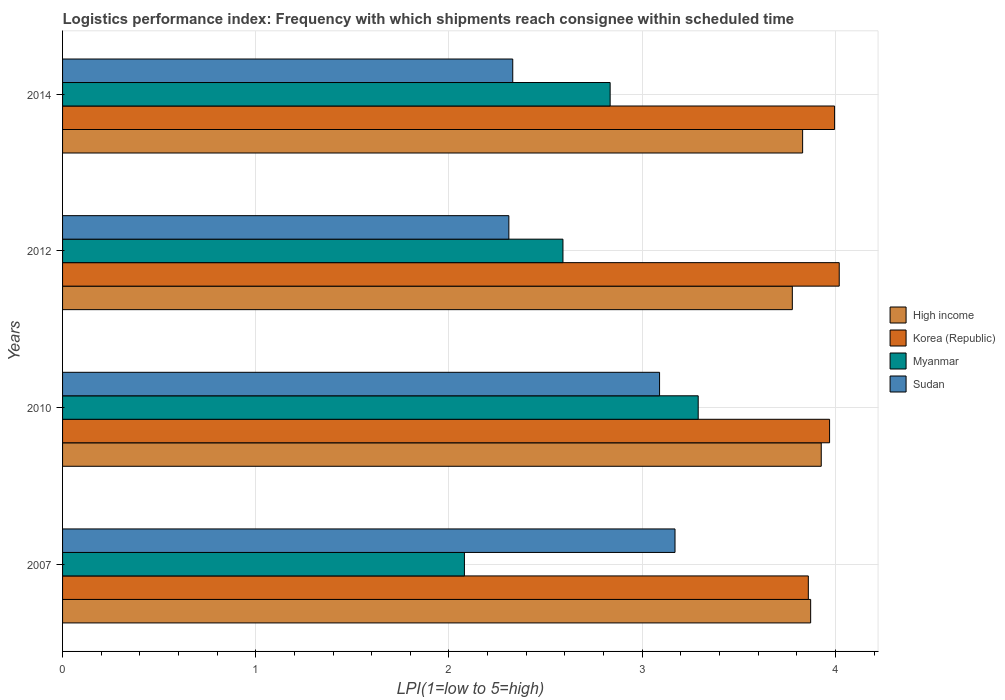Are the number of bars per tick equal to the number of legend labels?
Ensure brevity in your answer.  Yes. Are the number of bars on each tick of the Y-axis equal?
Your answer should be compact. Yes. What is the label of the 3rd group of bars from the top?
Your answer should be very brief. 2010. In how many cases, is the number of bars for a given year not equal to the number of legend labels?
Offer a terse response. 0. What is the logistics performance index in Korea (Republic) in 2007?
Provide a short and direct response. 3.86. Across all years, what is the maximum logistics performance index in High income?
Make the answer very short. 3.93. Across all years, what is the minimum logistics performance index in High income?
Provide a short and direct response. 3.78. What is the total logistics performance index in Sudan in the graph?
Your answer should be very brief. 10.9. What is the difference between the logistics performance index in High income in 2007 and that in 2010?
Ensure brevity in your answer.  -0.05. What is the difference between the logistics performance index in Sudan in 2014 and the logistics performance index in Myanmar in 2007?
Keep it short and to the point. 0.25. What is the average logistics performance index in Korea (Republic) per year?
Ensure brevity in your answer.  3.96. In the year 2007, what is the difference between the logistics performance index in Korea (Republic) and logistics performance index in High income?
Your answer should be compact. -0.01. In how many years, is the logistics performance index in Sudan greater than 1 ?
Make the answer very short. 4. What is the ratio of the logistics performance index in Myanmar in 2007 to that in 2014?
Your response must be concise. 0.73. Is the logistics performance index in Sudan in 2010 less than that in 2012?
Your answer should be very brief. No. Is the difference between the logistics performance index in Korea (Republic) in 2010 and 2012 greater than the difference between the logistics performance index in High income in 2010 and 2012?
Your response must be concise. No. What is the difference between the highest and the second highest logistics performance index in High income?
Give a very brief answer. 0.05. What is the difference between the highest and the lowest logistics performance index in Korea (Republic)?
Provide a short and direct response. 0.16. In how many years, is the logistics performance index in High income greater than the average logistics performance index in High income taken over all years?
Provide a succinct answer. 2. Is the sum of the logistics performance index in Korea (Republic) in 2007 and 2012 greater than the maximum logistics performance index in High income across all years?
Your response must be concise. Yes. What does the 4th bar from the top in 2014 represents?
Your answer should be compact. High income. What does the 3rd bar from the bottom in 2010 represents?
Give a very brief answer. Myanmar. How many bars are there?
Make the answer very short. 16. Does the graph contain any zero values?
Your response must be concise. No. How are the legend labels stacked?
Offer a very short reply. Vertical. What is the title of the graph?
Keep it short and to the point. Logistics performance index: Frequency with which shipments reach consignee within scheduled time. What is the label or title of the X-axis?
Your answer should be very brief. LPI(1=low to 5=high). What is the label or title of the Y-axis?
Provide a short and direct response. Years. What is the LPI(1=low to 5=high) of High income in 2007?
Your response must be concise. 3.87. What is the LPI(1=low to 5=high) in Korea (Republic) in 2007?
Make the answer very short. 3.86. What is the LPI(1=low to 5=high) in Myanmar in 2007?
Give a very brief answer. 2.08. What is the LPI(1=low to 5=high) of Sudan in 2007?
Make the answer very short. 3.17. What is the LPI(1=low to 5=high) in High income in 2010?
Give a very brief answer. 3.93. What is the LPI(1=low to 5=high) of Korea (Republic) in 2010?
Your response must be concise. 3.97. What is the LPI(1=low to 5=high) in Myanmar in 2010?
Offer a very short reply. 3.29. What is the LPI(1=low to 5=high) of Sudan in 2010?
Your response must be concise. 3.09. What is the LPI(1=low to 5=high) of High income in 2012?
Keep it short and to the point. 3.78. What is the LPI(1=low to 5=high) of Korea (Republic) in 2012?
Your answer should be very brief. 4.02. What is the LPI(1=low to 5=high) in Myanmar in 2012?
Offer a very short reply. 2.59. What is the LPI(1=low to 5=high) in Sudan in 2012?
Your response must be concise. 2.31. What is the LPI(1=low to 5=high) of High income in 2014?
Offer a very short reply. 3.83. What is the LPI(1=low to 5=high) of Korea (Republic) in 2014?
Provide a short and direct response. 4. What is the LPI(1=low to 5=high) in Myanmar in 2014?
Keep it short and to the point. 2.83. What is the LPI(1=low to 5=high) in Sudan in 2014?
Ensure brevity in your answer.  2.33. Across all years, what is the maximum LPI(1=low to 5=high) of High income?
Make the answer very short. 3.93. Across all years, what is the maximum LPI(1=low to 5=high) in Korea (Republic)?
Your response must be concise. 4.02. Across all years, what is the maximum LPI(1=low to 5=high) in Myanmar?
Your answer should be compact. 3.29. Across all years, what is the maximum LPI(1=low to 5=high) of Sudan?
Keep it short and to the point. 3.17. Across all years, what is the minimum LPI(1=low to 5=high) in High income?
Keep it short and to the point. 3.78. Across all years, what is the minimum LPI(1=low to 5=high) in Korea (Republic)?
Offer a terse response. 3.86. Across all years, what is the minimum LPI(1=low to 5=high) in Myanmar?
Ensure brevity in your answer.  2.08. Across all years, what is the minimum LPI(1=low to 5=high) in Sudan?
Offer a very short reply. 2.31. What is the total LPI(1=low to 5=high) of High income in the graph?
Provide a short and direct response. 15.41. What is the total LPI(1=low to 5=high) of Korea (Republic) in the graph?
Ensure brevity in your answer.  15.85. What is the total LPI(1=low to 5=high) of Myanmar in the graph?
Provide a short and direct response. 10.79. What is the total LPI(1=low to 5=high) in Sudan in the graph?
Your answer should be very brief. 10.9. What is the difference between the LPI(1=low to 5=high) in High income in 2007 and that in 2010?
Offer a very short reply. -0.05. What is the difference between the LPI(1=low to 5=high) in Korea (Republic) in 2007 and that in 2010?
Your answer should be compact. -0.11. What is the difference between the LPI(1=low to 5=high) of Myanmar in 2007 and that in 2010?
Give a very brief answer. -1.21. What is the difference between the LPI(1=low to 5=high) in High income in 2007 and that in 2012?
Your answer should be very brief. 0.09. What is the difference between the LPI(1=low to 5=high) in Korea (Republic) in 2007 and that in 2012?
Your answer should be very brief. -0.16. What is the difference between the LPI(1=low to 5=high) of Myanmar in 2007 and that in 2012?
Give a very brief answer. -0.51. What is the difference between the LPI(1=low to 5=high) in Sudan in 2007 and that in 2012?
Offer a terse response. 0.86. What is the difference between the LPI(1=low to 5=high) in High income in 2007 and that in 2014?
Make the answer very short. 0.04. What is the difference between the LPI(1=low to 5=high) in Korea (Republic) in 2007 and that in 2014?
Ensure brevity in your answer.  -0.14. What is the difference between the LPI(1=low to 5=high) of Myanmar in 2007 and that in 2014?
Offer a terse response. -0.75. What is the difference between the LPI(1=low to 5=high) of Sudan in 2007 and that in 2014?
Provide a short and direct response. 0.84. What is the difference between the LPI(1=low to 5=high) of High income in 2010 and that in 2012?
Offer a very short reply. 0.15. What is the difference between the LPI(1=low to 5=high) in Myanmar in 2010 and that in 2012?
Give a very brief answer. 0.7. What is the difference between the LPI(1=low to 5=high) in Sudan in 2010 and that in 2012?
Your answer should be very brief. 0.78. What is the difference between the LPI(1=low to 5=high) of High income in 2010 and that in 2014?
Ensure brevity in your answer.  0.1. What is the difference between the LPI(1=low to 5=high) in Korea (Republic) in 2010 and that in 2014?
Provide a succinct answer. -0.03. What is the difference between the LPI(1=low to 5=high) of Myanmar in 2010 and that in 2014?
Provide a succinct answer. 0.46. What is the difference between the LPI(1=low to 5=high) of Sudan in 2010 and that in 2014?
Ensure brevity in your answer.  0.76. What is the difference between the LPI(1=low to 5=high) of High income in 2012 and that in 2014?
Keep it short and to the point. -0.05. What is the difference between the LPI(1=low to 5=high) in Korea (Republic) in 2012 and that in 2014?
Offer a terse response. 0.02. What is the difference between the LPI(1=low to 5=high) in Myanmar in 2012 and that in 2014?
Offer a very short reply. -0.24. What is the difference between the LPI(1=low to 5=high) of Sudan in 2012 and that in 2014?
Keep it short and to the point. -0.02. What is the difference between the LPI(1=low to 5=high) of High income in 2007 and the LPI(1=low to 5=high) of Korea (Republic) in 2010?
Provide a succinct answer. -0.1. What is the difference between the LPI(1=low to 5=high) of High income in 2007 and the LPI(1=low to 5=high) of Myanmar in 2010?
Provide a succinct answer. 0.58. What is the difference between the LPI(1=low to 5=high) in High income in 2007 and the LPI(1=low to 5=high) in Sudan in 2010?
Offer a terse response. 0.78. What is the difference between the LPI(1=low to 5=high) of Korea (Republic) in 2007 and the LPI(1=low to 5=high) of Myanmar in 2010?
Keep it short and to the point. 0.57. What is the difference between the LPI(1=low to 5=high) in Korea (Republic) in 2007 and the LPI(1=low to 5=high) in Sudan in 2010?
Give a very brief answer. 0.77. What is the difference between the LPI(1=low to 5=high) in Myanmar in 2007 and the LPI(1=low to 5=high) in Sudan in 2010?
Provide a short and direct response. -1.01. What is the difference between the LPI(1=low to 5=high) in High income in 2007 and the LPI(1=low to 5=high) in Korea (Republic) in 2012?
Offer a very short reply. -0.15. What is the difference between the LPI(1=low to 5=high) of High income in 2007 and the LPI(1=low to 5=high) of Myanmar in 2012?
Your answer should be very brief. 1.28. What is the difference between the LPI(1=low to 5=high) of High income in 2007 and the LPI(1=low to 5=high) of Sudan in 2012?
Your answer should be very brief. 1.56. What is the difference between the LPI(1=low to 5=high) of Korea (Republic) in 2007 and the LPI(1=low to 5=high) of Myanmar in 2012?
Your answer should be very brief. 1.27. What is the difference between the LPI(1=low to 5=high) in Korea (Republic) in 2007 and the LPI(1=low to 5=high) in Sudan in 2012?
Offer a terse response. 1.55. What is the difference between the LPI(1=low to 5=high) in Myanmar in 2007 and the LPI(1=low to 5=high) in Sudan in 2012?
Your response must be concise. -0.23. What is the difference between the LPI(1=low to 5=high) of High income in 2007 and the LPI(1=low to 5=high) of Korea (Republic) in 2014?
Ensure brevity in your answer.  -0.12. What is the difference between the LPI(1=low to 5=high) of High income in 2007 and the LPI(1=low to 5=high) of Myanmar in 2014?
Offer a terse response. 1.04. What is the difference between the LPI(1=low to 5=high) of High income in 2007 and the LPI(1=low to 5=high) of Sudan in 2014?
Provide a succinct answer. 1.54. What is the difference between the LPI(1=low to 5=high) in Korea (Republic) in 2007 and the LPI(1=low to 5=high) in Myanmar in 2014?
Offer a very short reply. 1.03. What is the difference between the LPI(1=low to 5=high) of Korea (Republic) in 2007 and the LPI(1=low to 5=high) of Sudan in 2014?
Make the answer very short. 1.53. What is the difference between the LPI(1=low to 5=high) of Myanmar in 2007 and the LPI(1=low to 5=high) of Sudan in 2014?
Make the answer very short. -0.25. What is the difference between the LPI(1=low to 5=high) in High income in 2010 and the LPI(1=low to 5=high) in Korea (Republic) in 2012?
Your response must be concise. -0.09. What is the difference between the LPI(1=low to 5=high) of High income in 2010 and the LPI(1=low to 5=high) of Myanmar in 2012?
Offer a terse response. 1.34. What is the difference between the LPI(1=low to 5=high) of High income in 2010 and the LPI(1=low to 5=high) of Sudan in 2012?
Ensure brevity in your answer.  1.62. What is the difference between the LPI(1=low to 5=high) of Korea (Republic) in 2010 and the LPI(1=low to 5=high) of Myanmar in 2012?
Your answer should be compact. 1.38. What is the difference between the LPI(1=low to 5=high) of Korea (Republic) in 2010 and the LPI(1=low to 5=high) of Sudan in 2012?
Make the answer very short. 1.66. What is the difference between the LPI(1=low to 5=high) in High income in 2010 and the LPI(1=low to 5=high) in Korea (Republic) in 2014?
Make the answer very short. -0.07. What is the difference between the LPI(1=low to 5=high) in High income in 2010 and the LPI(1=low to 5=high) in Myanmar in 2014?
Provide a short and direct response. 1.09. What is the difference between the LPI(1=low to 5=high) in High income in 2010 and the LPI(1=low to 5=high) in Sudan in 2014?
Make the answer very short. 1.6. What is the difference between the LPI(1=low to 5=high) of Korea (Republic) in 2010 and the LPI(1=low to 5=high) of Myanmar in 2014?
Your answer should be very brief. 1.14. What is the difference between the LPI(1=low to 5=high) of Korea (Republic) in 2010 and the LPI(1=low to 5=high) of Sudan in 2014?
Ensure brevity in your answer.  1.64. What is the difference between the LPI(1=low to 5=high) in Myanmar in 2010 and the LPI(1=low to 5=high) in Sudan in 2014?
Ensure brevity in your answer.  0.96. What is the difference between the LPI(1=low to 5=high) in High income in 2012 and the LPI(1=low to 5=high) in Korea (Republic) in 2014?
Your answer should be compact. -0.22. What is the difference between the LPI(1=low to 5=high) in High income in 2012 and the LPI(1=low to 5=high) in Myanmar in 2014?
Your answer should be compact. 0.94. What is the difference between the LPI(1=low to 5=high) in High income in 2012 and the LPI(1=low to 5=high) in Sudan in 2014?
Make the answer very short. 1.45. What is the difference between the LPI(1=low to 5=high) of Korea (Republic) in 2012 and the LPI(1=low to 5=high) of Myanmar in 2014?
Offer a terse response. 1.19. What is the difference between the LPI(1=low to 5=high) of Korea (Republic) in 2012 and the LPI(1=low to 5=high) of Sudan in 2014?
Provide a succinct answer. 1.69. What is the difference between the LPI(1=low to 5=high) of Myanmar in 2012 and the LPI(1=low to 5=high) of Sudan in 2014?
Your answer should be very brief. 0.26. What is the average LPI(1=low to 5=high) of High income per year?
Your response must be concise. 3.85. What is the average LPI(1=low to 5=high) of Korea (Republic) per year?
Offer a terse response. 3.96. What is the average LPI(1=low to 5=high) in Myanmar per year?
Provide a succinct answer. 2.7. What is the average LPI(1=low to 5=high) of Sudan per year?
Provide a succinct answer. 2.73. In the year 2007, what is the difference between the LPI(1=low to 5=high) of High income and LPI(1=low to 5=high) of Korea (Republic)?
Offer a terse response. 0.01. In the year 2007, what is the difference between the LPI(1=low to 5=high) of High income and LPI(1=low to 5=high) of Myanmar?
Your response must be concise. 1.79. In the year 2007, what is the difference between the LPI(1=low to 5=high) of High income and LPI(1=low to 5=high) of Sudan?
Offer a terse response. 0.7. In the year 2007, what is the difference between the LPI(1=low to 5=high) in Korea (Republic) and LPI(1=low to 5=high) in Myanmar?
Your response must be concise. 1.78. In the year 2007, what is the difference between the LPI(1=low to 5=high) in Korea (Republic) and LPI(1=low to 5=high) in Sudan?
Ensure brevity in your answer.  0.69. In the year 2007, what is the difference between the LPI(1=low to 5=high) of Myanmar and LPI(1=low to 5=high) of Sudan?
Make the answer very short. -1.09. In the year 2010, what is the difference between the LPI(1=low to 5=high) of High income and LPI(1=low to 5=high) of Korea (Republic)?
Provide a succinct answer. -0.04. In the year 2010, what is the difference between the LPI(1=low to 5=high) in High income and LPI(1=low to 5=high) in Myanmar?
Provide a short and direct response. 0.64. In the year 2010, what is the difference between the LPI(1=low to 5=high) in High income and LPI(1=low to 5=high) in Sudan?
Provide a short and direct response. 0.84. In the year 2010, what is the difference between the LPI(1=low to 5=high) in Korea (Republic) and LPI(1=low to 5=high) in Myanmar?
Your response must be concise. 0.68. In the year 2012, what is the difference between the LPI(1=low to 5=high) in High income and LPI(1=low to 5=high) in Korea (Republic)?
Keep it short and to the point. -0.24. In the year 2012, what is the difference between the LPI(1=low to 5=high) in High income and LPI(1=low to 5=high) in Myanmar?
Provide a short and direct response. 1.19. In the year 2012, what is the difference between the LPI(1=low to 5=high) in High income and LPI(1=low to 5=high) in Sudan?
Keep it short and to the point. 1.47. In the year 2012, what is the difference between the LPI(1=low to 5=high) of Korea (Republic) and LPI(1=low to 5=high) of Myanmar?
Keep it short and to the point. 1.43. In the year 2012, what is the difference between the LPI(1=low to 5=high) in Korea (Republic) and LPI(1=low to 5=high) in Sudan?
Provide a short and direct response. 1.71. In the year 2012, what is the difference between the LPI(1=low to 5=high) in Myanmar and LPI(1=low to 5=high) in Sudan?
Keep it short and to the point. 0.28. In the year 2014, what is the difference between the LPI(1=low to 5=high) of High income and LPI(1=low to 5=high) of Korea (Republic)?
Offer a terse response. -0.17. In the year 2014, what is the difference between the LPI(1=low to 5=high) in High income and LPI(1=low to 5=high) in Sudan?
Provide a short and direct response. 1.5. In the year 2014, what is the difference between the LPI(1=low to 5=high) in Korea (Republic) and LPI(1=low to 5=high) in Myanmar?
Give a very brief answer. 1.16. In the year 2014, what is the difference between the LPI(1=low to 5=high) in Korea (Republic) and LPI(1=low to 5=high) in Sudan?
Provide a short and direct response. 1.67. In the year 2014, what is the difference between the LPI(1=low to 5=high) in Myanmar and LPI(1=low to 5=high) in Sudan?
Make the answer very short. 0.5. What is the ratio of the LPI(1=low to 5=high) of High income in 2007 to that in 2010?
Offer a terse response. 0.99. What is the ratio of the LPI(1=low to 5=high) of Korea (Republic) in 2007 to that in 2010?
Provide a succinct answer. 0.97. What is the ratio of the LPI(1=low to 5=high) in Myanmar in 2007 to that in 2010?
Make the answer very short. 0.63. What is the ratio of the LPI(1=low to 5=high) in Sudan in 2007 to that in 2010?
Provide a short and direct response. 1.03. What is the ratio of the LPI(1=low to 5=high) in High income in 2007 to that in 2012?
Provide a short and direct response. 1.03. What is the ratio of the LPI(1=low to 5=high) of Korea (Republic) in 2007 to that in 2012?
Your answer should be very brief. 0.96. What is the ratio of the LPI(1=low to 5=high) in Myanmar in 2007 to that in 2012?
Make the answer very short. 0.8. What is the ratio of the LPI(1=low to 5=high) of Sudan in 2007 to that in 2012?
Your response must be concise. 1.37. What is the ratio of the LPI(1=low to 5=high) in High income in 2007 to that in 2014?
Your answer should be very brief. 1.01. What is the ratio of the LPI(1=low to 5=high) of Myanmar in 2007 to that in 2014?
Your answer should be very brief. 0.73. What is the ratio of the LPI(1=low to 5=high) of Sudan in 2007 to that in 2014?
Give a very brief answer. 1.36. What is the ratio of the LPI(1=low to 5=high) in High income in 2010 to that in 2012?
Provide a succinct answer. 1.04. What is the ratio of the LPI(1=low to 5=high) of Korea (Republic) in 2010 to that in 2012?
Your response must be concise. 0.99. What is the ratio of the LPI(1=low to 5=high) in Myanmar in 2010 to that in 2012?
Provide a succinct answer. 1.27. What is the ratio of the LPI(1=low to 5=high) in Sudan in 2010 to that in 2012?
Keep it short and to the point. 1.34. What is the ratio of the LPI(1=low to 5=high) in High income in 2010 to that in 2014?
Provide a short and direct response. 1.03. What is the ratio of the LPI(1=low to 5=high) of Myanmar in 2010 to that in 2014?
Ensure brevity in your answer.  1.16. What is the ratio of the LPI(1=low to 5=high) in Sudan in 2010 to that in 2014?
Keep it short and to the point. 1.33. What is the ratio of the LPI(1=low to 5=high) of High income in 2012 to that in 2014?
Provide a short and direct response. 0.99. What is the ratio of the LPI(1=low to 5=high) of Myanmar in 2012 to that in 2014?
Ensure brevity in your answer.  0.91. What is the difference between the highest and the second highest LPI(1=low to 5=high) of High income?
Your answer should be very brief. 0.05. What is the difference between the highest and the second highest LPI(1=low to 5=high) of Korea (Republic)?
Provide a short and direct response. 0.02. What is the difference between the highest and the second highest LPI(1=low to 5=high) of Myanmar?
Provide a succinct answer. 0.46. What is the difference between the highest and the second highest LPI(1=low to 5=high) in Sudan?
Your response must be concise. 0.08. What is the difference between the highest and the lowest LPI(1=low to 5=high) of High income?
Ensure brevity in your answer.  0.15. What is the difference between the highest and the lowest LPI(1=low to 5=high) in Korea (Republic)?
Offer a very short reply. 0.16. What is the difference between the highest and the lowest LPI(1=low to 5=high) of Myanmar?
Your response must be concise. 1.21. What is the difference between the highest and the lowest LPI(1=low to 5=high) in Sudan?
Offer a very short reply. 0.86. 